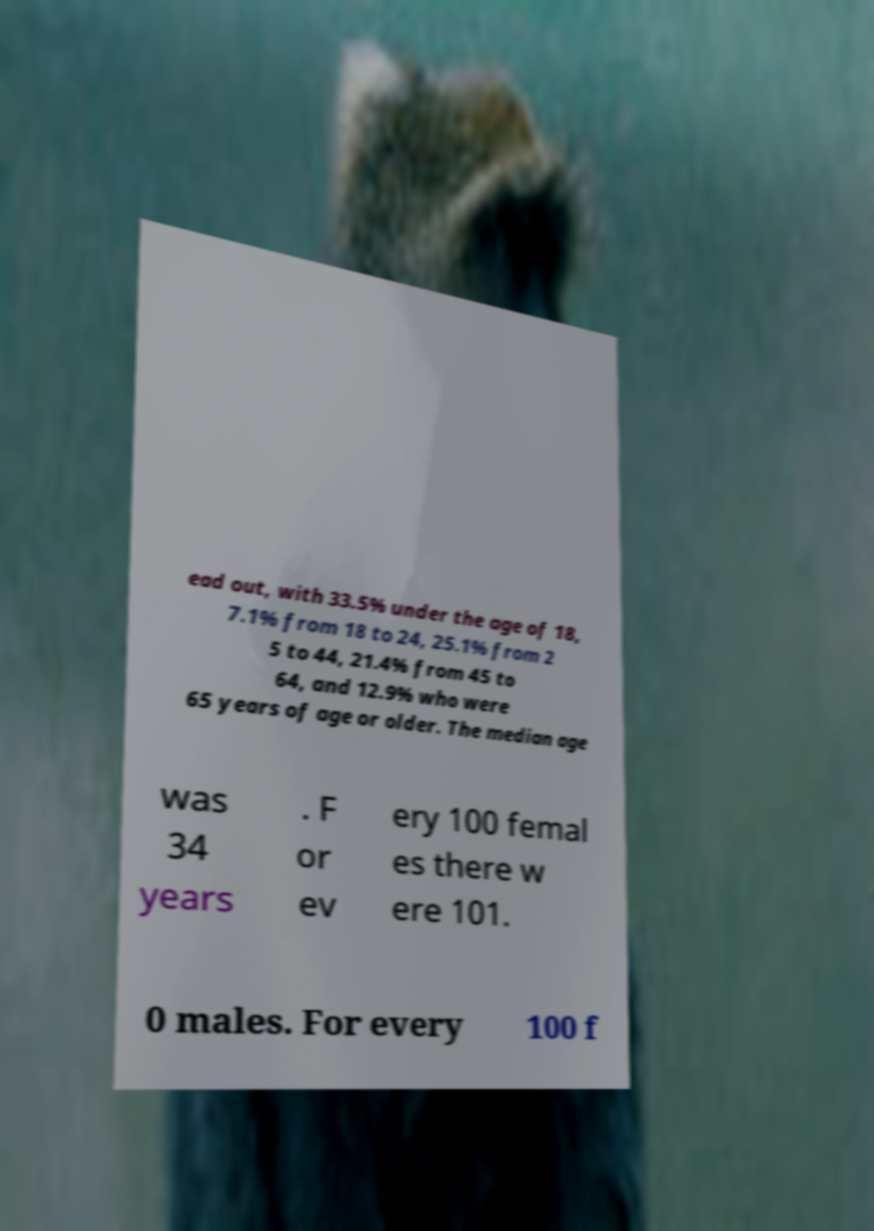What messages or text are displayed in this image? I need them in a readable, typed format. ead out, with 33.5% under the age of 18, 7.1% from 18 to 24, 25.1% from 2 5 to 44, 21.4% from 45 to 64, and 12.9% who were 65 years of age or older. The median age was 34 years . F or ev ery 100 femal es there w ere 101. 0 males. For every 100 f 